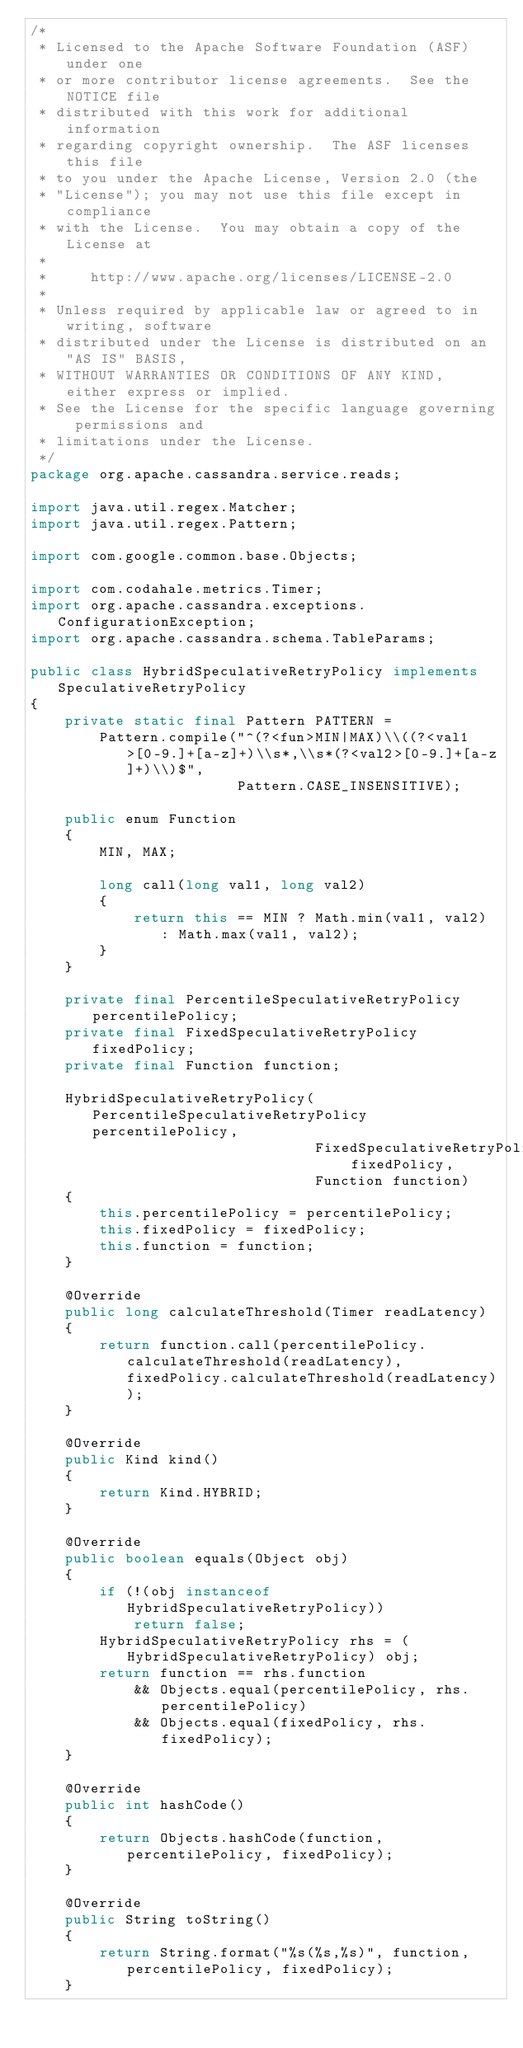<code> <loc_0><loc_0><loc_500><loc_500><_Java_>/*
 * Licensed to the Apache Software Foundation (ASF) under one
 * or more contributor license agreements.  See the NOTICE file
 * distributed with this work for additional information
 * regarding copyright ownership.  The ASF licenses this file
 * to you under the Apache License, Version 2.0 (the
 * "License"); you may not use this file except in compliance
 * with the License.  You may obtain a copy of the License at
 *
 *     http://www.apache.org/licenses/LICENSE-2.0
 *
 * Unless required by applicable law or agreed to in writing, software
 * distributed under the License is distributed on an "AS IS" BASIS,
 * WITHOUT WARRANTIES OR CONDITIONS OF ANY KIND, either express or implied.
 * See the License for the specific language governing permissions and
 * limitations under the License.
 */
package org.apache.cassandra.service.reads;

import java.util.regex.Matcher;
import java.util.regex.Pattern;

import com.google.common.base.Objects;

import com.codahale.metrics.Timer;
import org.apache.cassandra.exceptions.ConfigurationException;
import org.apache.cassandra.schema.TableParams;

public class HybridSpeculativeRetryPolicy implements SpeculativeRetryPolicy
{
    private static final Pattern PATTERN =
        Pattern.compile("^(?<fun>MIN|MAX)\\((?<val1>[0-9.]+[a-z]+)\\s*,\\s*(?<val2>[0-9.]+[a-z]+)\\)$",
                        Pattern.CASE_INSENSITIVE);

    public enum Function
    {
        MIN, MAX;

        long call(long val1, long val2)
        {
            return this == MIN ? Math.min(val1, val2) : Math.max(val1, val2);
        }
    }

    private final PercentileSpeculativeRetryPolicy percentilePolicy;
    private final FixedSpeculativeRetryPolicy fixedPolicy;
    private final Function function;

    HybridSpeculativeRetryPolicy(PercentileSpeculativeRetryPolicy percentilePolicy,
                                 FixedSpeculativeRetryPolicy fixedPolicy,
                                 Function function)
    {
        this.percentilePolicy = percentilePolicy;
        this.fixedPolicy = fixedPolicy;
        this.function = function;
    }

    @Override
    public long calculateThreshold(Timer readLatency)
    {
        return function.call(percentilePolicy.calculateThreshold(readLatency), fixedPolicy.calculateThreshold(readLatency));
    }

    @Override
    public Kind kind()
    {
        return Kind.HYBRID;
    }

    @Override
    public boolean equals(Object obj)
    {
        if (!(obj instanceof HybridSpeculativeRetryPolicy))
            return false;
        HybridSpeculativeRetryPolicy rhs = (HybridSpeculativeRetryPolicy) obj;
        return function == rhs.function
            && Objects.equal(percentilePolicy, rhs.percentilePolicy)
            && Objects.equal(fixedPolicy, rhs.fixedPolicy);
    }

    @Override
    public int hashCode()
    {
        return Objects.hashCode(function, percentilePolicy, fixedPolicy);
    }

    @Override
    public String toString()
    {
        return String.format("%s(%s,%s)", function, percentilePolicy, fixedPolicy);
    }
</code> 